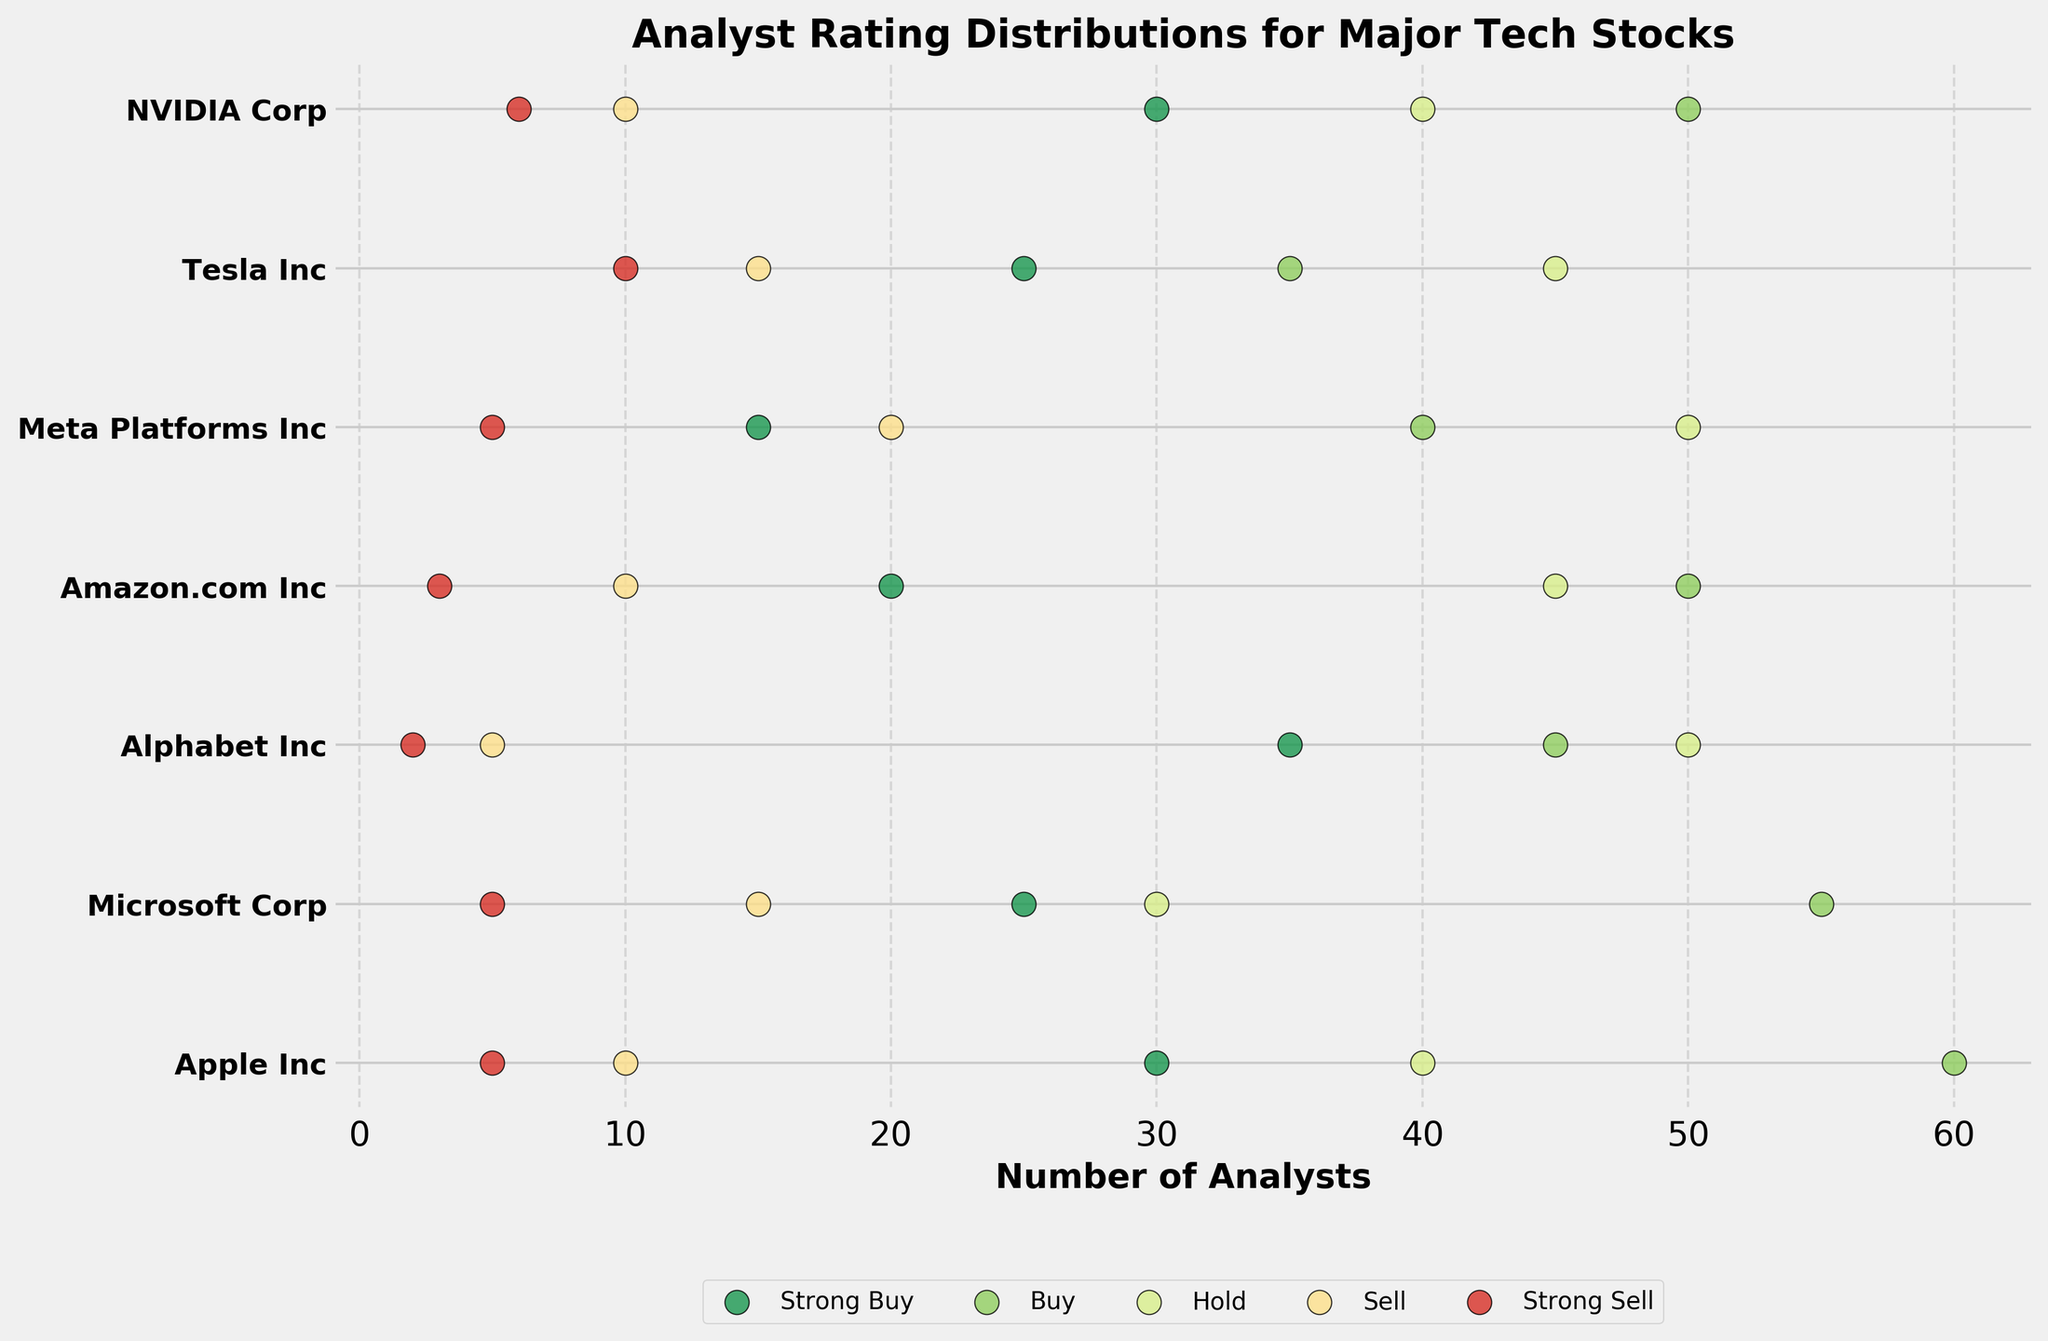What's the title of the plot? The title is displayed at the top of the plot. It reads "Analyst Rating Distributions for Major Tech Stocks".
Answer: Analyst Rating Distributions for Major Tech Stocks What does the x-axis represent? The label on the x-axis specifies that it represents "Number of Analysts".
Answer: Number of Analysts Which tech stock has the most "Strong Buy" recommendations? Look for the highest value (furthest point to the right) in the "Strong Buy" category (typically in green). Apple Inc has the most with 30 "Strong Buy" recommendations.
Answer: Apple Inc How many tech stocks have more than 20 "Hold" recommendations? Count the number of tick marks in the "Hold" category (typically in yellow-green) with values greater than 20. All the tech stocks listed have more than 20 "Hold" recommendations.
Answer: 7 Which stock has the fewest "Sell" recommendations? Identify the stock with the leftmost dot in the "Sell" category (typically in orange). Alphabet Inc has only 5 "Sell" recommendations.
Answer: Alphabet Inc Compare the number of "Strong Buy" and "Strong Sell" ratings for Microsoft Corp. Which is higher? Look at the positions of the dots for "Strong Buy" (typically in green) and "Strong Sell" (typically in red) for Microsoft Corp. "Strong Buy" has 25, while "Strong Sell" has 5. "Strong Buy" is higher.
Answer: Strong Buy What is the average number of "Buy" recommendations across all stocks? Add all "Buy" recommendations and divide by the total number of stocks. (60 + 55 + 45 + 50 + 40 + 35 + 50) / 7 = 335 / 7 ≈ 47.86.
Answer: 47.86 Which category has the most variability in the number of ratings across different stocks? Compare the spread of the dots for each category. "Hold" shows the most variability with values ranging from 30 to 50.
Answer: Hold What's the difference between the highest and lowest "Strong Buy" ratings? Subtract the smallest "Strong Buy" rating from the largest. The highest is 35 (Alphabet Inc), and the lowest is 15 (Meta Platforms Inc). 35 - 15 = 20.
Answer: 20 Which stock has the closest number of "Strong Buy" and "Sell" recommendations? Compare the "Strong Buy" and "Sell" recommendations for each stock and find the smallest difference. Microsoft Corp has 25 "Strong Buy" and 15 "Sell", a difference of 10.
Answer: Microsoft Corp 